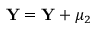Convert formula to latex. <formula><loc_0><loc_0><loc_500><loc_500>Y = Y + \mu _ { 2 }</formula> 